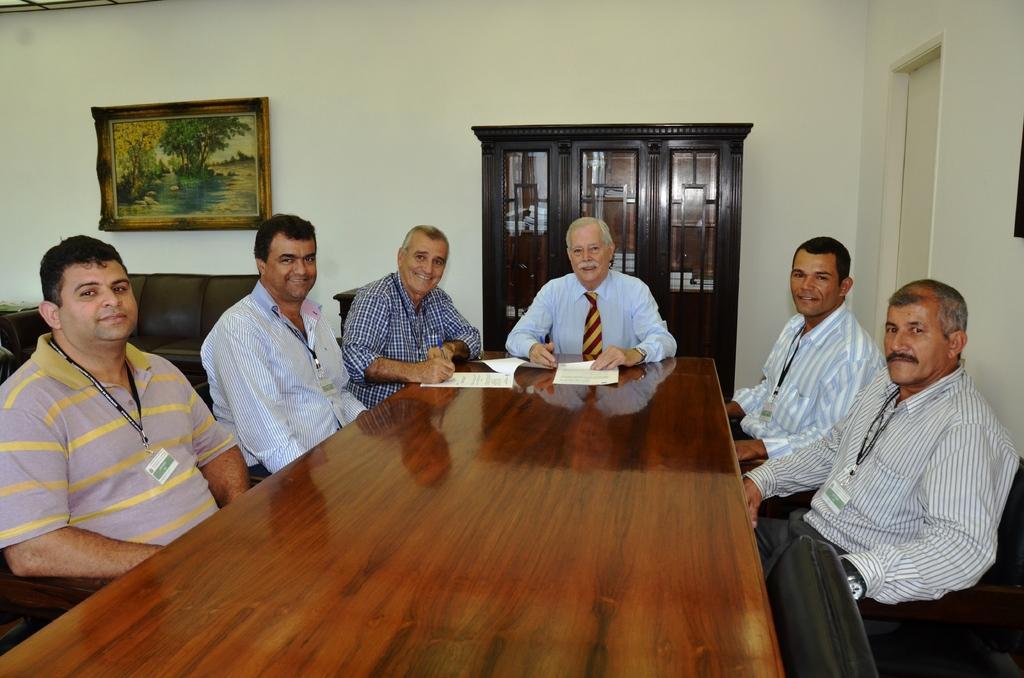What is happening in the image? There is a group of people in the image, and they are sitting. Where are the people sitting? They are sitting in front of a table. What is the color of the background wall? The background wall is white in color. Can you tell me how many towns are visible in the image? There are no towns visible in the image; it features a group of people sitting in front of a table with a white background wall. What type of stitch is being used by the aunt in the image? There is no aunt or any stitching activity present in the image. 